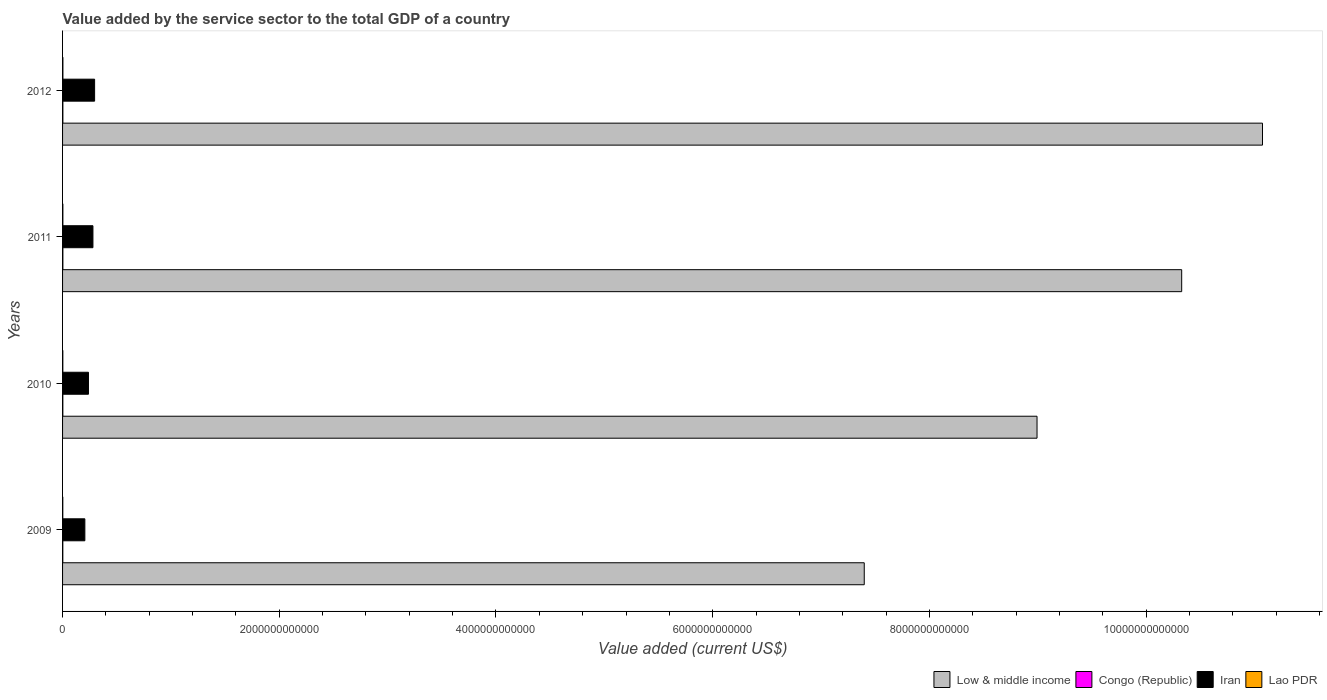How many different coloured bars are there?
Your response must be concise. 4. How many bars are there on the 3rd tick from the top?
Offer a very short reply. 4. How many bars are there on the 3rd tick from the bottom?
Offer a very short reply. 4. What is the value added by the service sector to the total GDP in Congo (Republic) in 2012?
Offer a terse response. 2.91e+09. Across all years, what is the maximum value added by the service sector to the total GDP in Low & middle income?
Offer a very short reply. 1.11e+13. Across all years, what is the minimum value added by the service sector to the total GDP in Low & middle income?
Give a very brief answer. 7.40e+12. What is the total value added by the service sector to the total GDP in Congo (Republic) in the graph?
Your answer should be compact. 1.06e+1. What is the difference between the value added by the service sector to the total GDP in Low & middle income in 2009 and that in 2010?
Keep it short and to the point. -1.59e+12. What is the difference between the value added by the service sector to the total GDP in Lao PDR in 2009 and the value added by the service sector to the total GDP in Low & middle income in 2011?
Offer a very short reply. -1.03e+13. What is the average value added by the service sector to the total GDP in Iran per year?
Offer a terse response. 2.55e+11. In the year 2010, what is the difference between the value added by the service sector to the total GDP in Low & middle income and value added by the service sector to the total GDP in Lao PDR?
Keep it short and to the point. 8.99e+12. What is the ratio of the value added by the service sector to the total GDP in Congo (Republic) in 2010 to that in 2011?
Ensure brevity in your answer.  0.87. What is the difference between the highest and the second highest value added by the service sector to the total GDP in Low & middle income?
Offer a terse response. 7.46e+11. What is the difference between the highest and the lowest value added by the service sector to the total GDP in Congo (Republic)?
Offer a terse response. 5.76e+08. In how many years, is the value added by the service sector to the total GDP in Low & middle income greater than the average value added by the service sector to the total GDP in Low & middle income taken over all years?
Your answer should be very brief. 2. Is the sum of the value added by the service sector to the total GDP in Congo (Republic) in 2010 and 2012 greater than the maximum value added by the service sector to the total GDP in Iran across all years?
Provide a short and direct response. No. What does the 3rd bar from the bottom in 2010 represents?
Offer a very short reply. Iran. Are all the bars in the graph horizontal?
Make the answer very short. Yes. How many years are there in the graph?
Give a very brief answer. 4. What is the difference between two consecutive major ticks on the X-axis?
Your answer should be very brief. 2.00e+12. How many legend labels are there?
Your answer should be very brief. 4. How are the legend labels stacked?
Give a very brief answer. Horizontal. What is the title of the graph?
Your answer should be compact. Value added by the service sector to the total GDP of a country. What is the label or title of the X-axis?
Ensure brevity in your answer.  Value added (current US$). What is the Value added (current US$) of Low & middle income in 2009?
Make the answer very short. 7.40e+12. What is the Value added (current US$) in Congo (Republic) in 2009?
Your answer should be compact. 2.34e+09. What is the Value added (current US$) in Iran in 2009?
Offer a terse response. 2.06e+11. What is the Value added (current US$) in Lao PDR in 2009?
Give a very brief answer. 2.11e+09. What is the Value added (current US$) in Low & middle income in 2010?
Give a very brief answer. 8.99e+12. What is the Value added (current US$) in Congo (Republic) in 2010?
Provide a succinct answer. 2.50e+09. What is the Value added (current US$) in Iran in 2010?
Make the answer very short. 2.39e+11. What is the Value added (current US$) in Lao PDR in 2010?
Give a very brief answer. 2.40e+09. What is the Value added (current US$) of Low & middle income in 2011?
Give a very brief answer. 1.03e+13. What is the Value added (current US$) of Congo (Republic) in 2011?
Your answer should be very brief. 2.88e+09. What is the Value added (current US$) of Iran in 2011?
Your answer should be compact. 2.80e+11. What is the Value added (current US$) of Lao PDR in 2011?
Your answer should be very brief. 2.79e+09. What is the Value added (current US$) of Low & middle income in 2012?
Offer a terse response. 1.11e+13. What is the Value added (current US$) in Congo (Republic) in 2012?
Make the answer very short. 2.91e+09. What is the Value added (current US$) of Iran in 2012?
Give a very brief answer. 2.96e+11. What is the Value added (current US$) in Lao PDR in 2012?
Make the answer very short. 3.17e+09. Across all years, what is the maximum Value added (current US$) of Low & middle income?
Give a very brief answer. 1.11e+13. Across all years, what is the maximum Value added (current US$) in Congo (Republic)?
Provide a short and direct response. 2.91e+09. Across all years, what is the maximum Value added (current US$) in Iran?
Ensure brevity in your answer.  2.96e+11. Across all years, what is the maximum Value added (current US$) in Lao PDR?
Ensure brevity in your answer.  3.17e+09. Across all years, what is the minimum Value added (current US$) of Low & middle income?
Keep it short and to the point. 7.40e+12. Across all years, what is the minimum Value added (current US$) of Congo (Republic)?
Your response must be concise. 2.34e+09. Across all years, what is the minimum Value added (current US$) in Iran?
Your answer should be compact. 2.06e+11. Across all years, what is the minimum Value added (current US$) of Lao PDR?
Provide a short and direct response. 2.11e+09. What is the total Value added (current US$) of Low & middle income in the graph?
Offer a very short reply. 3.78e+13. What is the total Value added (current US$) of Congo (Republic) in the graph?
Keep it short and to the point. 1.06e+1. What is the total Value added (current US$) in Iran in the graph?
Keep it short and to the point. 1.02e+12. What is the total Value added (current US$) of Lao PDR in the graph?
Offer a terse response. 1.05e+1. What is the difference between the Value added (current US$) of Low & middle income in 2009 and that in 2010?
Your answer should be very brief. -1.59e+12. What is the difference between the Value added (current US$) in Congo (Republic) in 2009 and that in 2010?
Keep it short and to the point. -1.58e+08. What is the difference between the Value added (current US$) of Iran in 2009 and that in 2010?
Make the answer very short. -3.34e+1. What is the difference between the Value added (current US$) in Lao PDR in 2009 and that in 2010?
Keep it short and to the point. -2.95e+08. What is the difference between the Value added (current US$) in Low & middle income in 2009 and that in 2011?
Keep it short and to the point. -2.93e+12. What is the difference between the Value added (current US$) in Congo (Republic) in 2009 and that in 2011?
Keep it short and to the point. -5.45e+08. What is the difference between the Value added (current US$) in Iran in 2009 and that in 2011?
Provide a succinct answer. -7.46e+1. What is the difference between the Value added (current US$) of Lao PDR in 2009 and that in 2011?
Keep it short and to the point. -6.83e+08. What is the difference between the Value added (current US$) of Low & middle income in 2009 and that in 2012?
Your answer should be very brief. -3.68e+12. What is the difference between the Value added (current US$) of Congo (Republic) in 2009 and that in 2012?
Offer a very short reply. -5.76e+08. What is the difference between the Value added (current US$) of Iran in 2009 and that in 2012?
Your answer should be very brief. -9.00e+1. What is the difference between the Value added (current US$) in Lao PDR in 2009 and that in 2012?
Make the answer very short. -1.06e+09. What is the difference between the Value added (current US$) in Low & middle income in 2010 and that in 2011?
Make the answer very short. -1.34e+12. What is the difference between the Value added (current US$) of Congo (Republic) in 2010 and that in 2011?
Your response must be concise. -3.87e+08. What is the difference between the Value added (current US$) of Iran in 2010 and that in 2011?
Give a very brief answer. -4.12e+1. What is the difference between the Value added (current US$) in Lao PDR in 2010 and that in 2011?
Offer a terse response. -3.88e+08. What is the difference between the Value added (current US$) of Low & middle income in 2010 and that in 2012?
Give a very brief answer. -2.08e+12. What is the difference between the Value added (current US$) of Congo (Republic) in 2010 and that in 2012?
Provide a succinct answer. -4.18e+08. What is the difference between the Value added (current US$) in Iran in 2010 and that in 2012?
Offer a terse response. -5.66e+1. What is the difference between the Value added (current US$) in Lao PDR in 2010 and that in 2012?
Your answer should be very brief. -7.68e+08. What is the difference between the Value added (current US$) of Low & middle income in 2011 and that in 2012?
Ensure brevity in your answer.  -7.46e+11. What is the difference between the Value added (current US$) in Congo (Republic) in 2011 and that in 2012?
Your answer should be very brief. -3.04e+07. What is the difference between the Value added (current US$) of Iran in 2011 and that in 2012?
Make the answer very short. -1.53e+1. What is the difference between the Value added (current US$) of Lao PDR in 2011 and that in 2012?
Keep it short and to the point. -3.80e+08. What is the difference between the Value added (current US$) in Low & middle income in 2009 and the Value added (current US$) in Congo (Republic) in 2010?
Your answer should be very brief. 7.40e+12. What is the difference between the Value added (current US$) in Low & middle income in 2009 and the Value added (current US$) in Iran in 2010?
Offer a very short reply. 7.16e+12. What is the difference between the Value added (current US$) in Low & middle income in 2009 and the Value added (current US$) in Lao PDR in 2010?
Your answer should be very brief. 7.40e+12. What is the difference between the Value added (current US$) of Congo (Republic) in 2009 and the Value added (current US$) of Iran in 2010?
Your response must be concise. -2.37e+11. What is the difference between the Value added (current US$) of Congo (Republic) in 2009 and the Value added (current US$) of Lao PDR in 2010?
Keep it short and to the point. -6.42e+07. What is the difference between the Value added (current US$) in Iran in 2009 and the Value added (current US$) in Lao PDR in 2010?
Provide a succinct answer. 2.03e+11. What is the difference between the Value added (current US$) in Low & middle income in 2009 and the Value added (current US$) in Congo (Republic) in 2011?
Give a very brief answer. 7.40e+12. What is the difference between the Value added (current US$) in Low & middle income in 2009 and the Value added (current US$) in Iran in 2011?
Provide a short and direct response. 7.12e+12. What is the difference between the Value added (current US$) in Low & middle income in 2009 and the Value added (current US$) in Lao PDR in 2011?
Offer a terse response. 7.40e+12. What is the difference between the Value added (current US$) in Congo (Republic) in 2009 and the Value added (current US$) in Iran in 2011?
Give a very brief answer. -2.78e+11. What is the difference between the Value added (current US$) in Congo (Republic) in 2009 and the Value added (current US$) in Lao PDR in 2011?
Keep it short and to the point. -4.52e+08. What is the difference between the Value added (current US$) of Iran in 2009 and the Value added (current US$) of Lao PDR in 2011?
Your answer should be very brief. 2.03e+11. What is the difference between the Value added (current US$) of Low & middle income in 2009 and the Value added (current US$) of Congo (Republic) in 2012?
Your answer should be very brief. 7.40e+12. What is the difference between the Value added (current US$) of Low & middle income in 2009 and the Value added (current US$) of Iran in 2012?
Your response must be concise. 7.10e+12. What is the difference between the Value added (current US$) of Low & middle income in 2009 and the Value added (current US$) of Lao PDR in 2012?
Make the answer very short. 7.40e+12. What is the difference between the Value added (current US$) of Congo (Republic) in 2009 and the Value added (current US$) of Iran in 2012?
Your answer should be compact. -2.93e+11. What is the difference between the Value added (current US$) of Congo (Republic) in 2009 and the Value added (current US$) of Lao PDR in 2012?
Give a very brief answer. -8.32e+08. What is the difference between the Value added (current US$) of Iran in 2009 and the Value added (current US$) of Lao PDR in 2012?
Give a very brief answer. 2.03e+11. What is the difference between the Value added (current US$) in Low & middle income in 2010 and the Value added (current US$) in Congo (Republic) in 2011?
Ensure brevity in your answer.  8.99e+12. What is the difference between the Value added (current US$) of Low & middle income in 2010 and the Value added (current US$) of Iran in 2011?
Offer a very short reply. 8.71e+12. What is the difference between the Value added (current US$) of Low & middle income in 2010 and the Value added (current US$) of Lao PDR in 2011?
Offer a terse response. 8.99e+12. What is the difference between the Value added (current US$) in Congo (Republic) in 2010 and the Value added (current US$) in Iran in 2011?
Ensure brevity in your answer.  -2.78e+11. What is the difference between the Value added (current US$) of Congo (Republic) in 2010 and the Value added (current US$) of Lao PDR in 2011?
Ensure brevity in your answer.  -2.94e+08. What is the difference between the Value added (current US$) in Iran in 2010 and the Value added (current US$) in Lao PDR in 2011?
Offer a very short reply. 2.36e+11. What is the difference between the Value added (current US$) of Low & middle income in 2010 and the Value added (current US$) of Congo (Republic) in 2012?
Offer a very short reply. 8.99e+12. What is the difference between the Value added (current US$) of Low & middle income in 2010 and the Value added (current US$) of Iran in 2012?
Ensure brevity in your answer.  8.70e+12. What is the difference between the Value added (current US$) of Low & middle income in 2010 and the Value added (current US$) of Lao PDR in 2012?
Your answer should be compact. 8.99e+12. What is the difference between the Value added (current US$) in Congo (Republic) in 2010 and the Value added (current US$) in Iran in 2012?
Keep it short and to the point. -2.93e+11. What is the difference between the Value added (current US$) in Congo (Republic) in 2010 and the Value added (current US$) in Lao PDR in 2012?
Ensure brevity in your answer.  -6.74e+08. What is the difference between the Value added (current US$) in Iran in 2010 and the Value added (current US$) in Lao PDR in 2012?
Give a very brief answer. 2.36e+11. What is the difference between the Value added (current US$) in Low & middle income in 2011 and the Value added (current US$) in Congo (Republic) in 2012?
Make the answer very short. 1.03e+13. What is the difference between the Value added (current US$) in Low & middle income in 2011 and the Value added (current US$) in Iran in 2012?
Offer a very short reply. 1.00e+13. What is the difference between the Value added (current US$) in Low & middle income in 2011 and the Value added (current US$) in Lao PDR in 2012?
Your answer should be very brief. 1.03e+13. What is the difference between the Value added (current US$) in Congo (Republic) in 2011 and the Value added (current US$) in Iran in 2012?
Your answer should be very brief. -2.93e+11. What is the difference between the Value added (current US$) of Congo (Republic) in 2011 and the Value added (current US$) of Lao PDR in 2012?
Give a very brief answer. -2.87e+08. What is the difference between the Value added (current US$) of Iran in 2011 and the Value added (current US$) of Lao PDR in 2012?
Provide a short and direct response. 2.77e+11. What is the average Value added (current US$) in Low & middle income per year?
Give a very brief answer. 9.45e+12. What is the average Value added (current US$) in Congo (Republic) per year?
Provide a succinct answer. 2.66e+09. What is the average Value added (current US$) of Iran per year?
Offer a terse response. 2.55e+11. What is the average Value added (current US$) in Lao PDR per year?
Your answer should be compact. 2.62e+09. In the year 2009, what is the difference between the Value added (current US$) of Low & middle income and Value added (current US$) of Congo (Republic)?
Provide a short and direct response. 7.40e+12. In the year 2009, what is the difference between the Value added (current US$) in Low & middle income and Value added (current US$) in Iran?
Your answer should be compact. 7.19e+12. In the year 2009, what is the difference between the Value added (current US$) in Low & middle income and Value added (current US$) in Lao PDR?
Keep it short and to the point. 7.40e+12. In the year 2009, what is the difference between the Value added (current US$) of Congo (Republic) and Value added (current US$) of Iran?
Your answer should be very brief. -2.03e+11. In the year 2009, what is the difference between the Value added (current US$) of Congo (Republic) and Value added (current US$) of Lao PDR?
Your answer should be very brief. 2.30e+08. In the year 2009, what is the difference between the Value added (current US$) in Iran and Value added (current US$) in Lao PDR?
Provide a short and direct response. 2.04e+11. In the year 2010, what is the difference between the Value added (current US$) in Low & middle income and Value added (current US$) in Congo (Republic)?
Ensure brevity in your answer.  8.99e+12. In the year 2010, what is the difference between the Value added (current US$) of Low & middle income and Value added (current US$) of Iran?
Offer a very short reply. 8.75e+12. In the year 2010, what is the difference between the Value added (current US$) of Low & middle income and Value added (current US$) of Lao PDR?
Make the answer very short. 8.99e+12. In the year 2010, what is the difference between the Value added (current US$) of Congo (Republic) and Value added (current US$) of Iran?
Your response must be concise. -2.37e+11. In the year 2010, what is the difference between the Value added (current US$) of Congo (Republic) and Value added (current US$) of Lao PDR?
Make the answer very short. 9.39e+07. In the year 2010, what is the difference between the Value added (current US$) of Iran and Value added (current US$) of Lao PDR?
Ensure brevity in your answer.  2.37e+11. In the year 2011, what is the difference between the Value added (current US$) of Low & middle income and Value added (current US$) of Congo (Republic)?
Offer a terse response. 1.03e+13. In the year 2011, what is the difference between the Value added (current US$) of Low & middle income and Value added (current US$) of Iran?
Ensure brevity in your answer.  1.00e+13. In the year 2011, what is the difference between the Value added (current US$) of Low & middle income and Value added (current US$) of Lao PDR?
Give a very brief answer. 1.03e+13. In the year 2011, what is the difference between the Value added (current US$) of Congo (Republic) and Value added (current US$) of Iran?
Provide a succinct answer. -2.77e+11. In the year 2011, what is the difference between the Value added (current US$) of Congo (Republic) and Value added (current US$) of Lao PDR?
Keep it short and to the point. 9.28e+07. In the year 2011, what is the difference between the Value added (current US$) of Iran and Value added (current US$) of Lao PDR?
Offer a very short reply. 2.78e+11. In the year 2012, what is the difference between the Value added (current US$) of Low & middle income and Value added (current US$) of Congo (Republic)?
Keep it short and to the point. 1.11e+13. In the year 2012, what is the difference between the Value added (current US$) in Low & middle income and Value added (current US$) in Iran?
Make the answer very short. 1.08e+13. In the year 2012, what is the difference between the Value added (current US$) in Low & middle income and Value added (current US$) in Lao PDR?
Keep it short and to the point. 1.11e+13. In the year 2012, what is the difference between the Value added (current US$) in Congo (Republic) and Value added (current US$) in Iran?
Make the answer very short. -2.93e+11. In the year 2012, what is the difference between the Value added (current US$) in Congo (Republic) and Value added (current US$) in Lao PDR?
Offer a terse response. -2.56e+08. In the year 2012, what is the difference between the Value added (current US$) in Iran and Value added (current US$) in Lao PDR?
Offer a terse response. 2.92e+11. What is the ratio of the Value added (current US$) of Low & middle income in 2009 to that in 2010?
Your answer should be compact. 0.82. What is the ratio of the Value added (current US$) in Congo (Republic) in 2009 to that in 2010?
Your answer should be very brief. 0.94. What is the ratio of the Value added (current US$) of Iran in 2009 to that in 2010?
Keep it short and to the point. 0.86. What is the ratio of the Value added (current US$) of Lao PDR in 2009 to that in 2010?
Offer a terse response. 0.88. What is the ratio of the Value added (current US$) in Low & middle income in 2009 to that in 2011?
Provide a succinct answer. 0.72. What is the ratio of the Value added (current US$) of Congo (Republic) in 2009 to that in 2011?
Give a very brief answer. 0.81. What is the ratio of the Value added (current US$) in Iran in 2009 to that in 2011?
Your response must be concise. 0.73. What is the ratio of the Value added (current US$) of Lao PDR in 2009 to that in 2011?
Make the answer very short. 0.76. What is the ratio of the Value added (current US$) of Low & middle income in 2009 to that in 2012?
Ensure brevity in your answer.  0.67. What is the ratio of the Value added (current US$) of Congo (Republic) in 2009 to that in 2012?
Your answer should be compact. 0.8. What is the ratio of the Value added (current US$) in Iran in 2009 to that in 2012?
Keep it short and to the point. 0.7. What is the ratio of the Value added (current US$) of Lao PDR in 2009 to that in 2012?
Keep it short and to the point. 0.66. What is the ratio of the Value added (current US$) of Low & middle income in 2010 to that in 2011?
Keep it short and to the point. 0.87. What is the ratio of the Value added (current US$) of Congo (Republic) in 2010 to that in 2011?
Your response must be concise. 0.87. What is the ratio of the Value added (current US$) in Iran in 2010 to that in 2011?
Offer a very short reply. 0.85. What is the ratio of the Value added (current US$) in Lao PDR in 2010 to that in 2011?
Keep it short and to the point. 0.86. What is the ratio of the Value added (current US$) of Low & middle income in 2010 to that in 2012?
Your response must be concise. 0.81. What is the ratio of the Value added (current US$) in Congo (Republic) in 2010 to that in 2012?
Your answer should be very brief. 0.86. What is the ratio of the Value added (current US$) of Iran in 2010 to that in 2012?
Provide a short and direct response. 0.81. What is the ratio of the Value added (current US$) of Lao PDR in 2010 to that in 2012?
Provide a short and direct response. 0.76. What is the ratio of the Value added (current US$) in Low & middle income in 2011 to that in 2012?
Give a very brief answer. 0.93. What is the ratio of the Value added (current US$) of Congo (Republic) in 2011 to that in 2012?
Provide a short and direct response. 0.99. What is the ratio of the Value added (current US$) of Iran in 2011 to that in 2012?
Your answer should be very brief. 0.95. What is the ratio of the Value added (current US$) of Lao PDR in 2011 to that in 2012?
Keep it short and to the point. 0.88. What is the difference between the highest and the second highest Value added (current US$) of Low & middle income?
Your response must be concise. 7.46e+11. What is the difference between the highest and the second highest Value added (current US$) of Congo (Republic)?
Offer a very short reply. 3.04e+07. What is the difference between the highest and the second highest Value added (current US$) of Iran?
Provide a succinct answer. 1.53e+1. What is the difference between the highest and the second highest Value added (current US$) in Lao PDR?
Keep it short and to the point. 3.80e+08. What is the difference between the highest and the lowest Value added (current US$) of Low & middle income?
Ensure brevity in your answer.  3.68e+12. What is the difference between the highest and the lowest Value added (current US$) of Congo (Republic)?
Offer a terse response. 5.76e+08. What is the difference between the highest and the lowest Value added (current US$) of Iran?
Give a very brief answer. 9.00e+1. What is the difference between the highest and the lowest Value added (current US$) of Lao PDR?
Keep it short and to the point. 1.06e+09. 